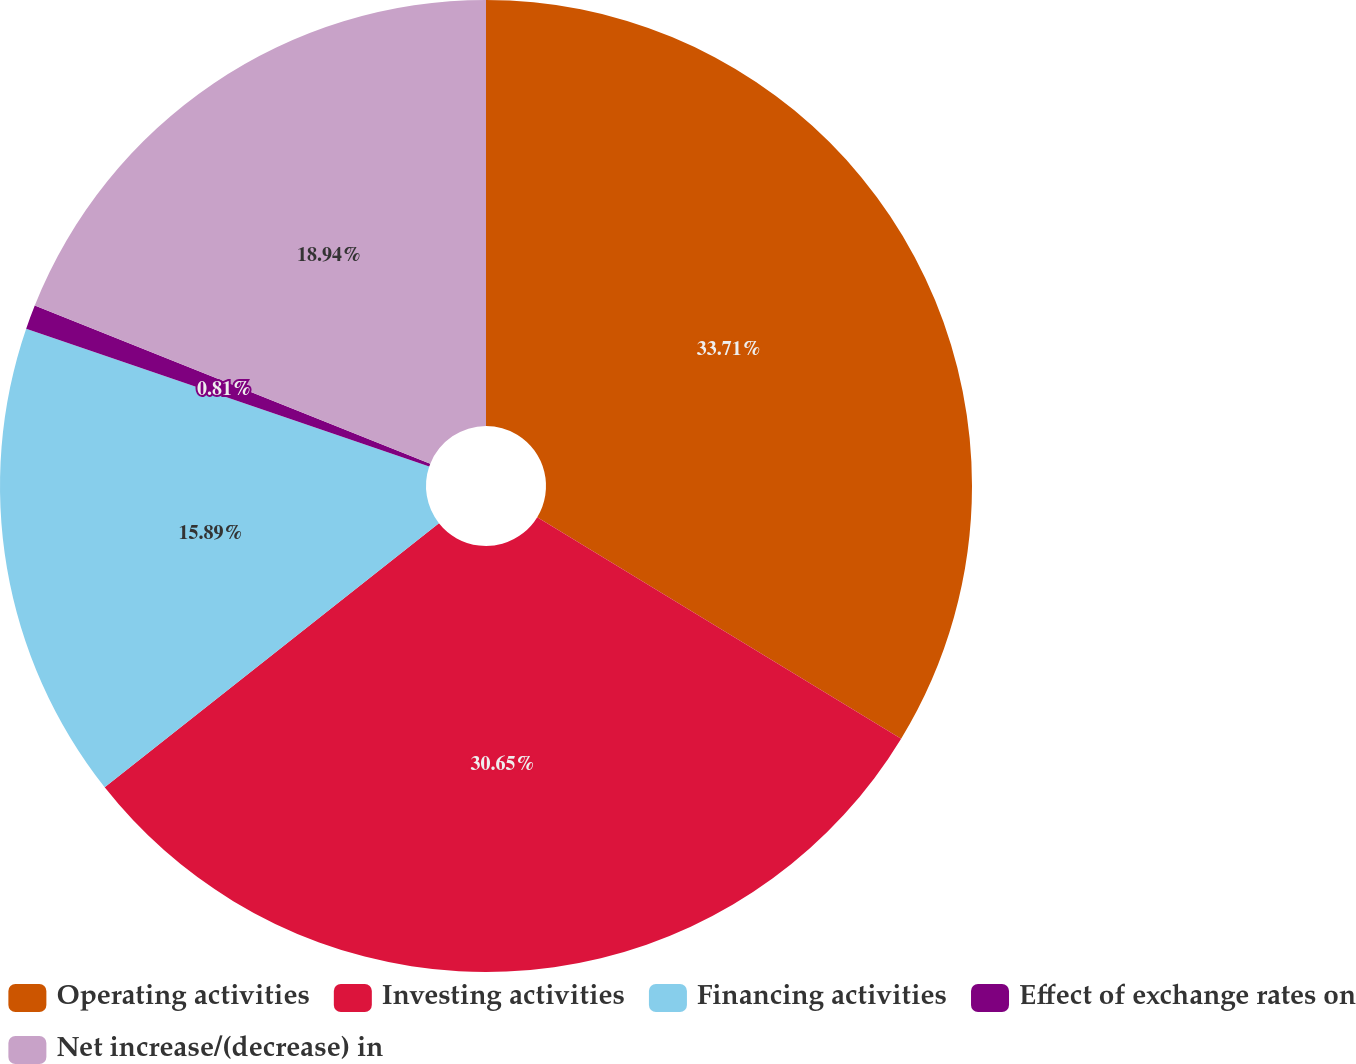Convert chart. <chart><loc_0><loc_0><loc_500><loc_500><pie_chart><fcel>Operating activities<fcel>Investing activities<fcel>Financing activities<fcel>Effect of exchange rates on<fcel>Net increase/(decrease) in<nl><fcel>33.7%<fcel>30.65%<fcel>15.89%<fcel>0.81%<fcel>18.94%<nl></chart> 